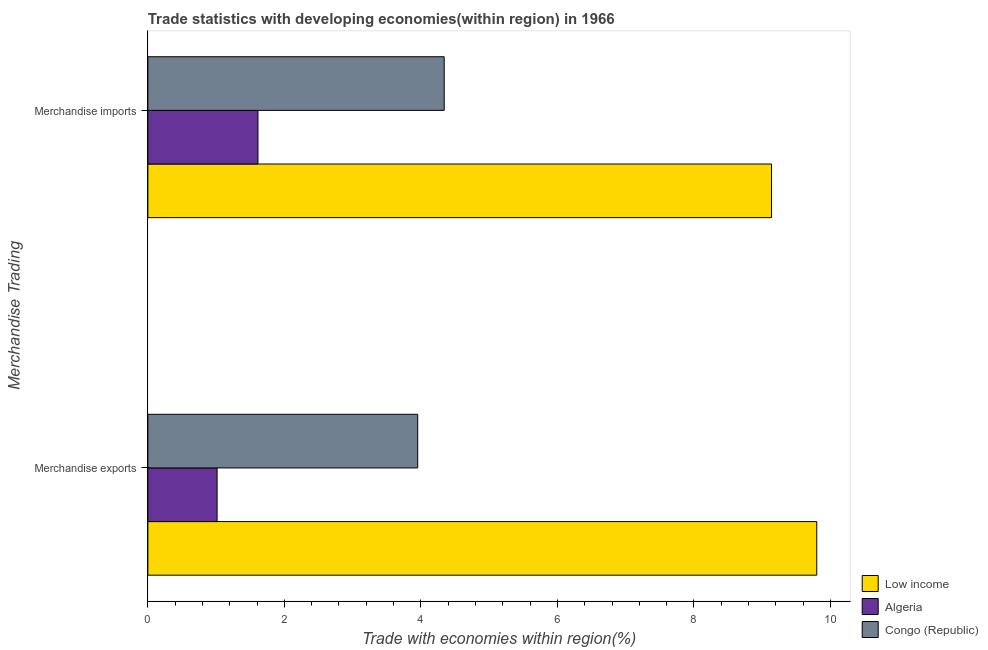How many groups of bars are there?
Provide a succinct answer. 2. Are the number of bars per tick equal to the number of legend labels?
Ensure brevity in your answer.  Yes. What is the merchandise imports in Low income?
Provide a succinct answer. 9.14. Across all countries, what is the maximum merchandise exports?
Ensure brevity in your answer.  9.8. Across all countries, what is the minimum merchandise exports?
Provide a succinct answer. 1.01. In which country was the merchandise exports minimum?
Give a very brief answer. Algeria. What is the total merchandise exports in the graph?
Provide a short and direct response. 14.77. What is the difference between the merchandise exports in Congo (Republic) and that in Low income?
Offer a very short reply. -5.85. What is the difference between the merchandise exports in Algeria and the merchandise imports in Low income?
Provide a succinct answer. -8.12. What is the average merchandise exports per country?
Keep it short and to the point. 4.92. What is the difference between the merchandise imports and merchandise exports in Algeria?
Ensure brevity in your answer.  0.6. What is the ratio of the merchandise imports in Congo (Republic) to that in Algeria?
Ensure brevity in your answer.  2.69. Is the merchandise exports in Algeria less than that in Congo (Republic)?
Provide a short and direct response. Yes. What does the 1st bar from the top in Merchandise imports represents?
Offer a terse response. Congo (Republic). What does the 2nd bar from the bottom in Merchandise exports represents?
Keep it short and to the point. Algeria. How many bars are there?
Ensure brevity in your answer.  6. Are all the bars in the graph horizontal?
Provide a succinct answer. Yes. What is the difference between two consecutive major ticks on the X-axis?
Your answer should be very brief. 2. Does the graph contain grids?
Keep it short and to the point. No. How many legend labels are there?
Provide a succinct answer. 3. How are the legend labels stacked?
Keep it short and to the point. Vertical. What is the title of the graph?
Your answer should be very brief. Trade statistics with developing economies(within region) in 1966. Does "Austria" appear as one of the legend labels in the graph?
Provide a short and direct response. No. What is the label or title of the X-axis?
Your answer should be compact. Trade with economies within region(%). What is the label or title of the Y-axis?
Give a very brief answer. Merchandise Trading. What is the Trade with economies within region(%) in Low income in Merchandise exports?
Provide a short and direct response. 9.8. What is the Trade with economies within region(%) of Algeria in Merchandise exports?
Provide a short and direct response. 1.01. What is the Trade with economies within region(%) in Congo (Republic) in Merchandise exports?
Your answer should be very brief. 3.95. What is the Trade with economies within region(%) of Low income in Merchandise imports?
Provide a short and direct response. 9.14. What is the Trade with economies within region(%) of Algeria in Merchandise imports?
Keep it short and to the point. 1.61. What is the Trade with economies within region(%) in Congo (Republic) in Merchandise imports?
Ensure brevity in your answer.  4.34. Across all Merchandise Trading, what is the maximum Trade with economies within region(%) of Low income?
Provide a short and direct response. 9.8. Across all Merchandise Trading, what is the maximum Trade with economies within region(%) of Algeria?
Your answer should be compact. 1.61. Across all Merchandise Trading, what is the maximum Trade with economies within region(%) in Congo (Republic)?
Make the answer very short. 4.34. Across all Merchandise Trading, what is the minimum Trade with economies within region(%) in Low income?
Offer a very short reply. 9.14. Across all Merchandise Trading, what is the minimum Trade with economies within region(%) of Algeria?
Keep it short and to the point. 1.01. Across all Merchandise Trading, what is the minimum Trade with economies within region(%) in Congo (Republic)?
Give a very brief answer. 3.95. What is the total Trade with economies within region(%) of Low income in the graph?
Your response must be concise. 18.94. What is the total Trade with economies within region(%) of Algeria in the graph?
Give a very brief answer. 2.63. What is the total Trade with economies within region(%) of Congo (Republic) in the graph?
Give a very brief answer. 8.29. What is the difference between the Trade with economies within region(%) in Low income in Merchandise exports and that in Merchandise imports?
Keep it short and to the point. 0.66. What is the difference between the Trade with economies within region(%) of Algeria in Merchandise exports and that in Merchandise imports?
Your response must be concise. -0.6. What is the difference between the Trade with economies within region(%) in Congo (Republic) in Merchandise exports and that in Merchandise imports?
Your response must be concise. -0.39. What is the difference between the Trade with economies within region(%) in Low income in Merchandise exports and the Trade with economies within region(%) in Algeria in Merchandise imports?
Offer a terse response. 8.19. What is the difference between the Trade with economies within region(%) in Low income in Merchandise exports and the Trade with economies within region(%) in Congo (Republic) in Merchandise imports?
Provide a short and direct response. 5.46. What is the difference between the Trade with economies within region(%) in Algeria in Merchandise exports and the Trade with economies within region(%) in Congo (Republic) in Merchandise imports?
Your answer should be compact. -3.33. What is the average Trade with economies within region(%) in Low income per Merchandise Trading?
Provide a short and direct response. 9.47. What is the average Trade with economies within region(%) of Algeria per Merchandise Trading?
Offer a very short reply. 1.31. What is the average Trade with economies within region(%) in Congo (Republic) per Merchandise Trading?
Provide a succinct answer. 4.15. What is the difference between the Trade with economies within region(%) in Low income and Trade with economies within region(%) in Algeria in Merchandise exports?
Offer a terse response. 8.79. What is the difference between the Trade with economies within region(%) in Low income and Trade with economies within region(%) in Congo (Republic) in Merchandise exports?
Provide a short and direct response. 5.85. What is the difference between the Trade with economies within region(%) in Algeria and Trade with economies within region(%) in Congo (Republic) in Merchandise exports?
Ensure brevity in your answer.  -2.94. What is the difference between the Trade with economies within region(%) of Low income and Trade with economies within region(%) of Algeria in Merchandise imports?
Provide a succinct answer. 7.52. What is the difference between the Trade with economies within region(%) in Low income and Trade with economies within region(%) in Congo (Republic) in Merchandise imports?
Keep it short and to the point. 4.8. What is the difference between the Trade with economies within region(%) of Algeria and Trade with economies within region(%) of Congo (Republic) in Merchandise imports?
Make the answer very short. -2.73. What is the ratio of the Trade with economies within region(%) in Low income in Merchandise exports to that in Merchandise imports?
Give a very brief answer. 1.07. What is the ratio of the Trade with economies within region(%) of Algeria in Merchandise exports to that in Merchandise imports?
Make the answer very short. 0.63. What is the ratio of the Trade with economies within region(%) of Congo (Republic) in Merchandise exports to that in Merchandise imports?
Your response must be concise. 0.91. What is the difference between the highest and the second highest Trade with economies within region(%) of Low income?
Offer a very short reply. 0.66. What is the difference between the highest and the second highest Trade with economies within region(%) in Algeria?
Your answer should be very brief. 0.6. What is the difference between the highest and the second highest Trade with economies within region(%) of Congo (Republic)?
Make the answer very short. 0.39. What is the difference between the highest and the lowest Trade with economies within region(%) of Low income?
Give a very brief answer. 0.66. What is the difference between the highest and the lowest Trade with economies within region(%) in Algeria?
Provide a short and direct response. 0.6. What is the difference between the highest and the lowest Trade with economies within region(%) in Congo (Republic)?
Your answer should be very brief. 0.39. 